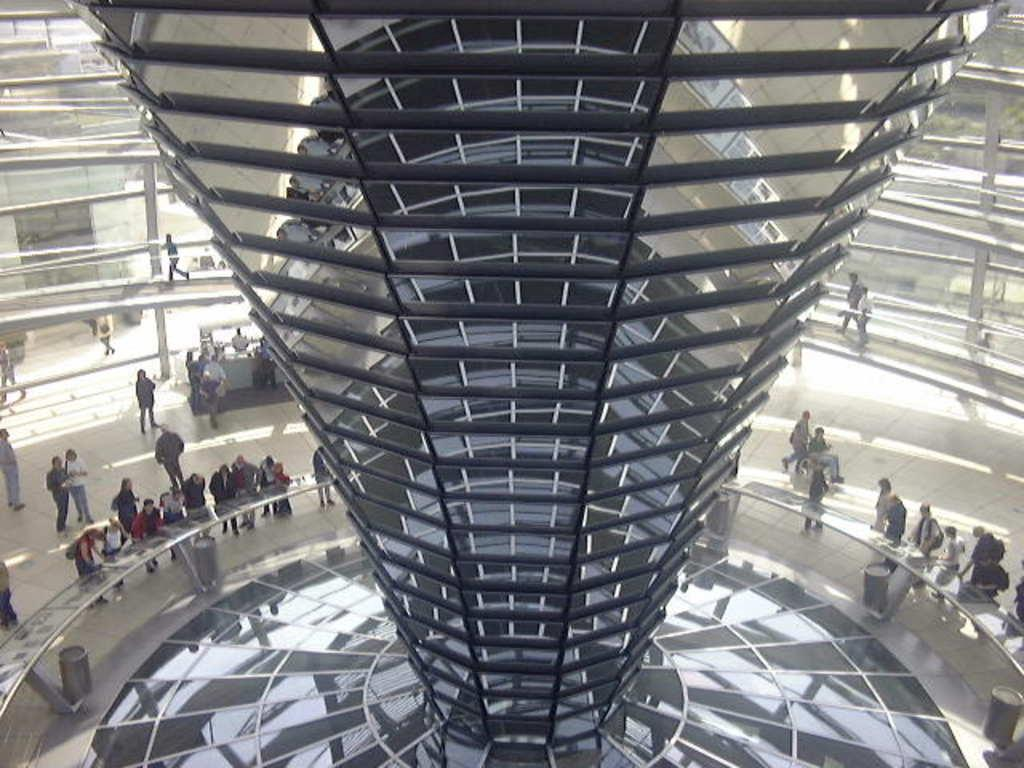How many people are in the image? There is a group of people in the image. What are some of the people in the image doing? Some people are standing, and some people are walking. What can be seen in the middle of the image? There is a tower in the middle of the image. What type of frame is holding the people together in the image? There is no frame holding the people together in the image; they are standing or walking independently. 